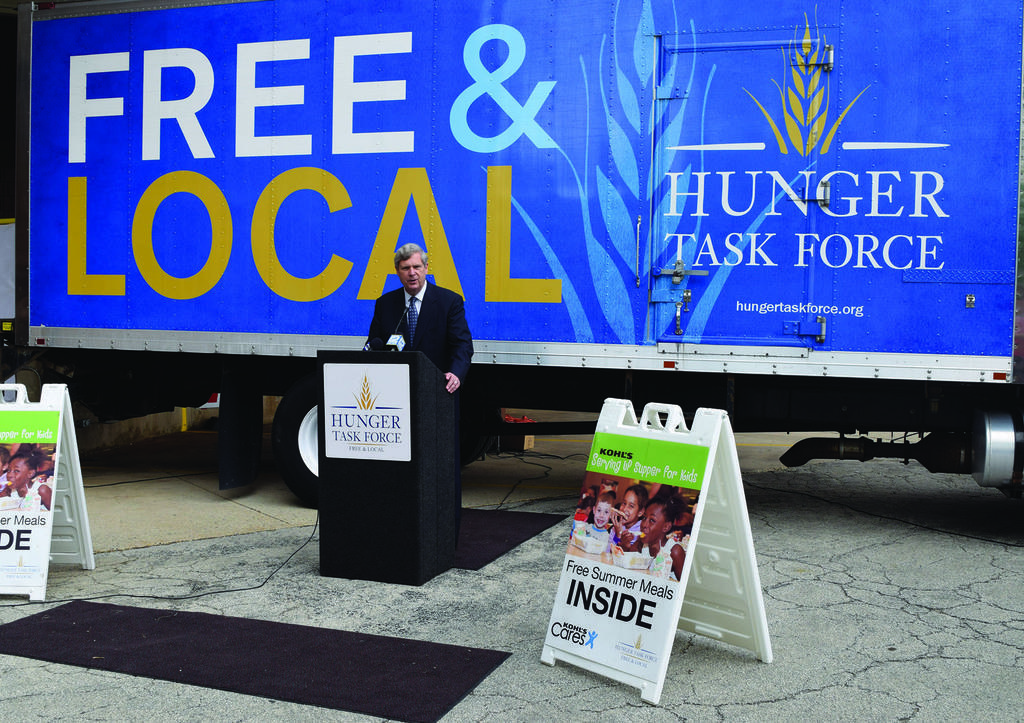Please provide a concise description of this image. In this image there is a man standing in the middle. In front of him there is a podium on which there is a mic. Behind him there is a truck. On the truck there is a poster. At the bottom there is a mat in the middle. Beside the mat there are two boards on either side of it. 